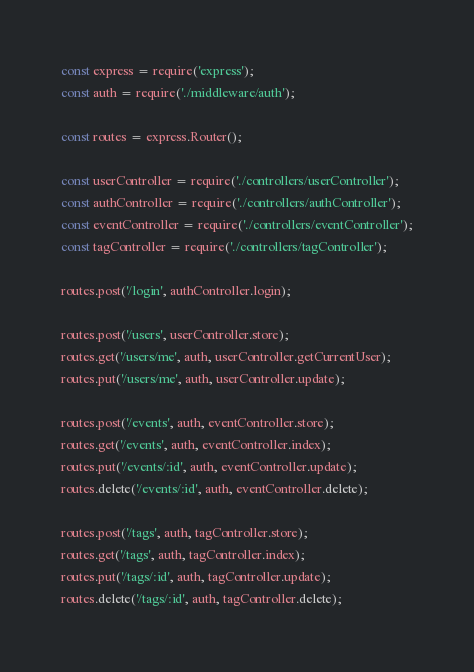<code> <loc_0><loc_0><loc_500><loc_500><_JavaScript_>const express = require('express');
const auth = require('./middleware/auth');

const routes = express.Router();

const userController = require('./controllers/userController');
const authController = require('./controllers/authController');
const eventController = require('./controllers/eventController');
const tagController = require('./controllers/tagController');

routes.post('/login', authController.login);

routes.post('/users', userController.store);
routes.get('/users/me', auth, userController.getCurrentUser);
routes.put('/users/me', auth, userController.update);

routes.post('/events', auth, eventController.store);
routes.get('/events', auth, eventController.index);
routes.put('/events/:id', auth, eventController.update);
routes.delete('/events/:id', auth, eventController.delete);

routes.post('/tags', auth, tagController.store);
routes.get('/tags', auth, tagController.index);
routes.put('/tags/:id', auth, tagController.update);
routes.delete('/tags/:id', auth, tagController.delete);
</code> 